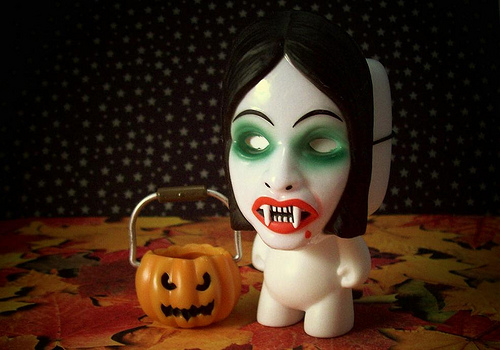<image>
Is there a pumpkin on the fangs? No. The pumpkin is not positioned on the fangs. They may be near each other, but the pumpkin is not supported by or resting on top of the fangs. Is there a handle in front of the doll? No. The handle is not in front of the doll. The spatial positioning shows a different relationship between these objects. 